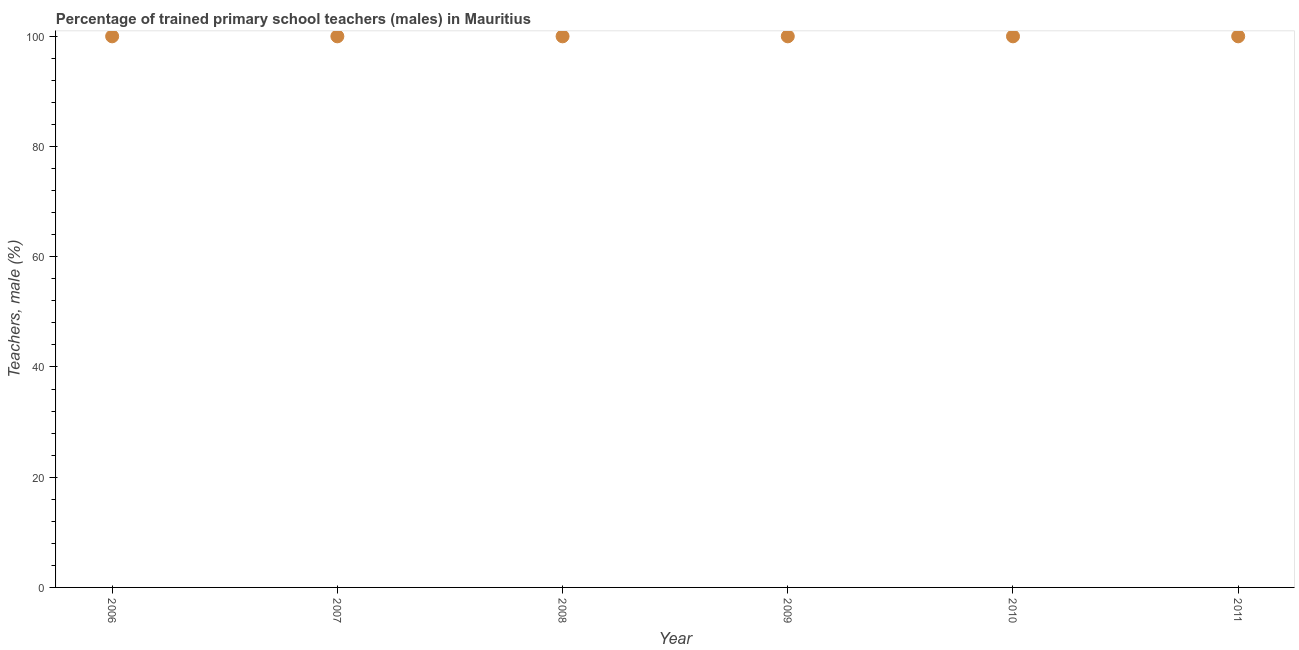What is the percentage of trained male teachers in 2009?
Provide a short and direct response. 100. Across all years, what is the maximum percentage of trained male teachers?
Offer a terse response. 100. Across all years, what is the minimum percentage of trained male teachers?
Your answer should be compact. 100. What is the sum of the percentage of trained male teachers?
Give a very brief answer. 600. What is the difference between the percentage of trained male teachers in 2006 and 2007?
Offer a very short reply. 0. What is the average percentage of trained male teachers per year?
Make the answer very short. 100. Is the difference between the percentage of trained male teachers in 2006 and 2011 greater than the difference between any two years?
Offer a terse response. Yes. What is the difference between the highest and the lowest percentage of trained male teachers?
Your answer should be very brief. 0. In how many years, is the percentage of trained male teachers greater than the average percentage of trained male teachers taken over all years?
Offer a very short reply. 0. Does the graph contain any zero values?
Give a very brief answer. No. Does the graph contain grids?
Your response must be concise. No. What is the title of the graph?
Give a very brief answer. Percentage of trained primary school teachers (males) in Mauritius. What is the label or title of the X-axis?
Your answer should be compact. Year. What is the label or title of the Y-axis?
Give a very brief answer. Teachers, male (%). What is the Teachers, male (%) in 2007?
Your response must be concise. 100. What is the Teachers, male (%) in 2009?
Provide a succinct answer. 100. What is the Teachers, male (%) in 2011?
Make the answer very short. 100. What is the difference between the Teachers, male (%) in 2006 and 2010?
Provide a short and direct response. 0. What is the difference between the Teachers, male (%) in 2006 and 2011?
Provide a short and direct response. 0. What is the difference between the Teachers, male (%) in 2007 and 2008?
Provide a short and direct response. 0. What is the difference between the Teachers, male (%) in 2007 and 2009?
Offer a terse response. 0. What is the difference between the Teachers, male (%) in 2008 and 2010?
Provide a succinct answer. 0. What is the difference between the Teachers, male (%) in 2008 and 2011?
Offer a terse response. 0. What is the difference between the Teachers, male (%) in 2009 and 2010?
Ensure brevity in your answer.  0. What is the difference between the Teachers, male (%) in 2010 and 2011?
Offer a very short reply. 0. What is the ratio of the Teachers, male (%) in 2006 to that in 2007?
Make the answer very short. 1. What is the ratio of the Teachers, male (%) in 2006 to that in 2008?
Give a very brief answer. 1. What is the ratio of the Teachers, male (%) in 2006 to that in 2009?
Offer a terse response. 1. What is the ratio of the Teachers, male (%) in 2006 to that in 2010?
Your answer should be very brief. 1. What is the ratio of the Teachers, male (%) in 2007 to that in 2011?
Give a very brief answer. 1. What is the ratio of the Teachers, male (%) in 2008 to that in 2011?
Offer a terse response. 1. What is the ratio of the Teachers, male (%) in 2009 to that in 2010?
Give a very brief answer. 1. What is the ratio of the Teachers, male (%) in 2009 to that in 2011?
Your answer should be compact. 1. 